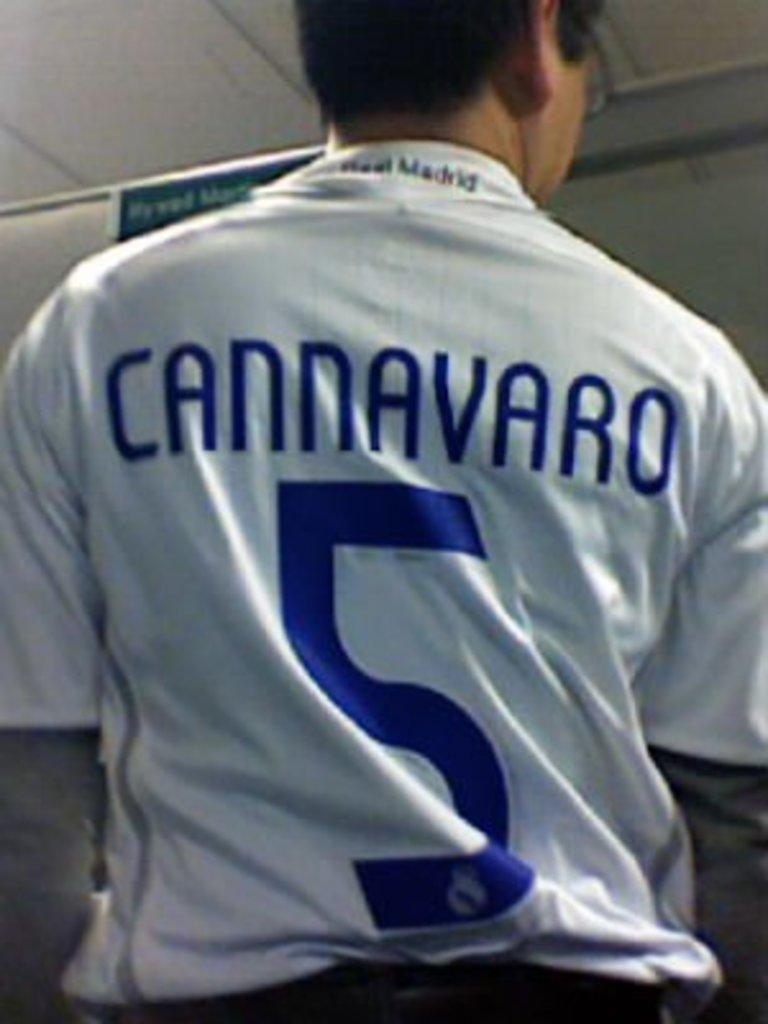<image>
Relay a brief, clear account of the picture shown. A man is wearing a blue and white Cannavaro number 5 jersey. 